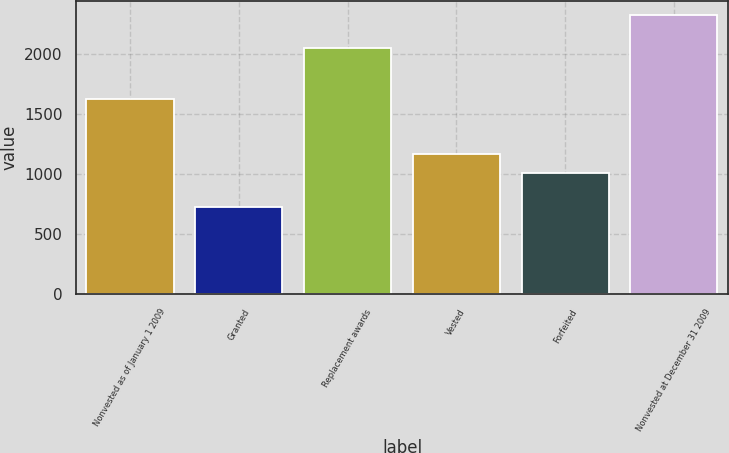Convert chart. <chart><loc_0><loc_0><loc_500><loc_500><bar_chart><fcel>Nonvested as of January 1 2009<fcel>Granted<fcel>Replacement awards<fcel>Vested<fcel>Forfeited<fcel>Nonvested at December 31 2009<nl><fcel>1621.4<fcel>726.4<fcel>2049.9<fcel>1171.02<fcel>1011.4<fcel>2322.6<nl></chart> 